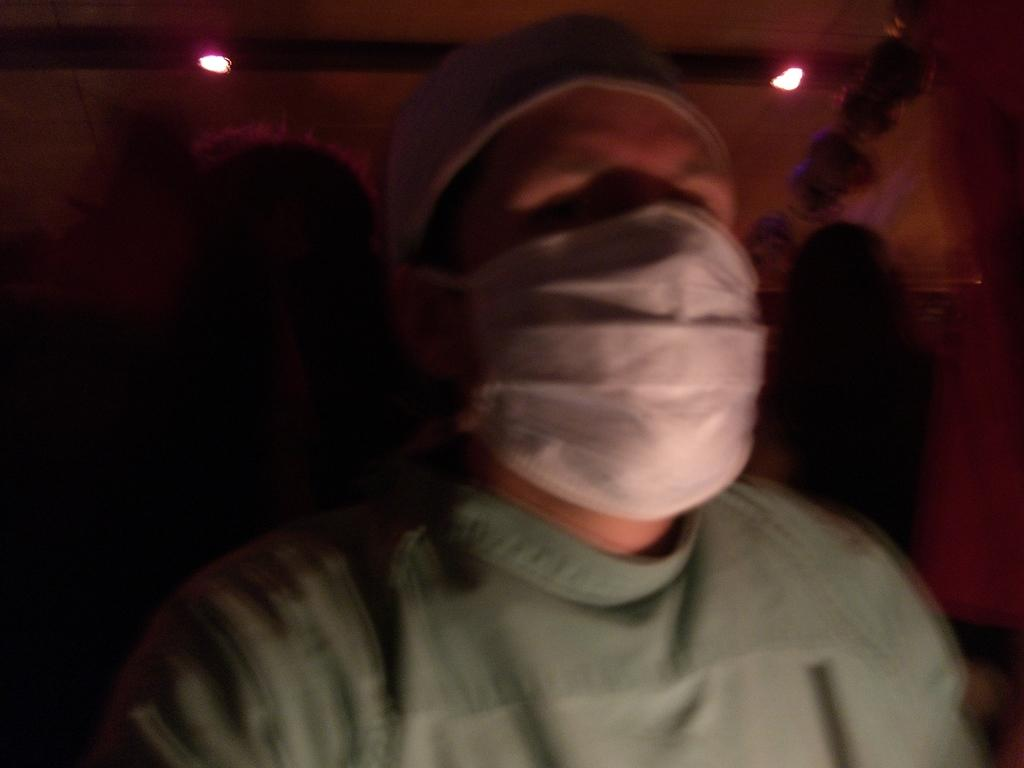Who or what is the main subject in the image? There is a person in the center of the image. What is the person wearing on their head? The person is wearing a white color cap. What is the person wearing on their face? The person is wearing a mask. Can you describe the background of the image? The background of the image is not clear. What type of soup is being served on the shelf in the image? There is no shelf or soup present in the image; it features a person wearing a cap and mask. 